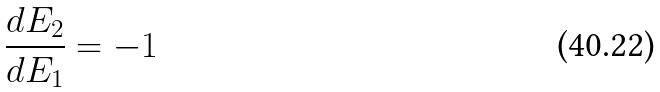Convert formula to latex. <formula><loc_0><loc_0><loc_500><loc_500>\frac { d E _ { 2 } } { d E _ { 1 } } = - 1</formula> 